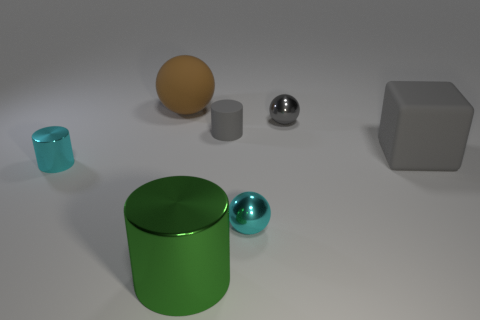Subtract all tiny gray cylinders. How many cylinders are left? 2 Subtract all brown balls. How many balls are left? 2 Add 3 large gray objects. How many objects exist? 10 Subtract all cubes. How many objects are left? 6 Subtract all red cylinders. Subtract all yellow balls. How many cylinders are left? 3 Subtract all green cylinders. How many cyan spheres are left? 1 Subtract all tiny rubber blocks. Subtract all cyan shiny balls. How many objects are left? 6 Add 4 big gray objects. How many big gray objects are left? 5 Add 5 small red matte cylinders. How many small red matte cylinders exist? 5 Subtract 1 gray blocks. How many objects are left? 6 